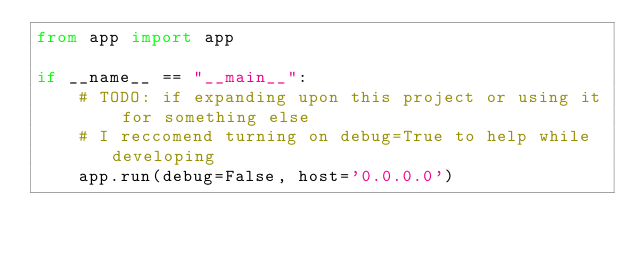Convert code to text. <code><loc_0><loc_0><loc_500><loc_500><_Python_>from app import app

if __name__ == "__main__":
    # TODO: if expanding upon this project or using it for something else
    # I reccomend turning on debug=True to help while developing
    app.run(debug=False, host='0.0.0.0')</code> 